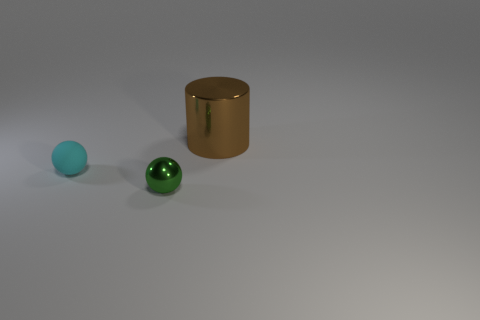What is the material of the tiny object that is behind the green sphere?
Make the answer very short. Rubber. Are there any brown shiny things that have the same shape as the small green object?
Keep it short and to the point. No. How many other things are there of the same shape as the large brown object?
Make the answer very short. 0. Is the shape of the green thing the same as the metal object behind the tiny green metal sphere?
Your answer should be compact. No. Is there any other thing that is made of the same material as the green ball?
Offer a very short reply. Yes. There is another thing that is the same shape as the cyan matte object; what is it made of?
Your answer should be compact. Metal. What number of large things are metallic objects or brown metallic things?
Your answer should be compact. 1. Are there fewer metal things that are to the left of the green metallic ball than cyan matte objects behind the brown metal cylinder?
Your response must be concise. No. What number of things are either green things or small balls?
Keep it short and to the point. 2. What number of green metal balls are right of the matte ball?
Provide a succinct answer. 1. 